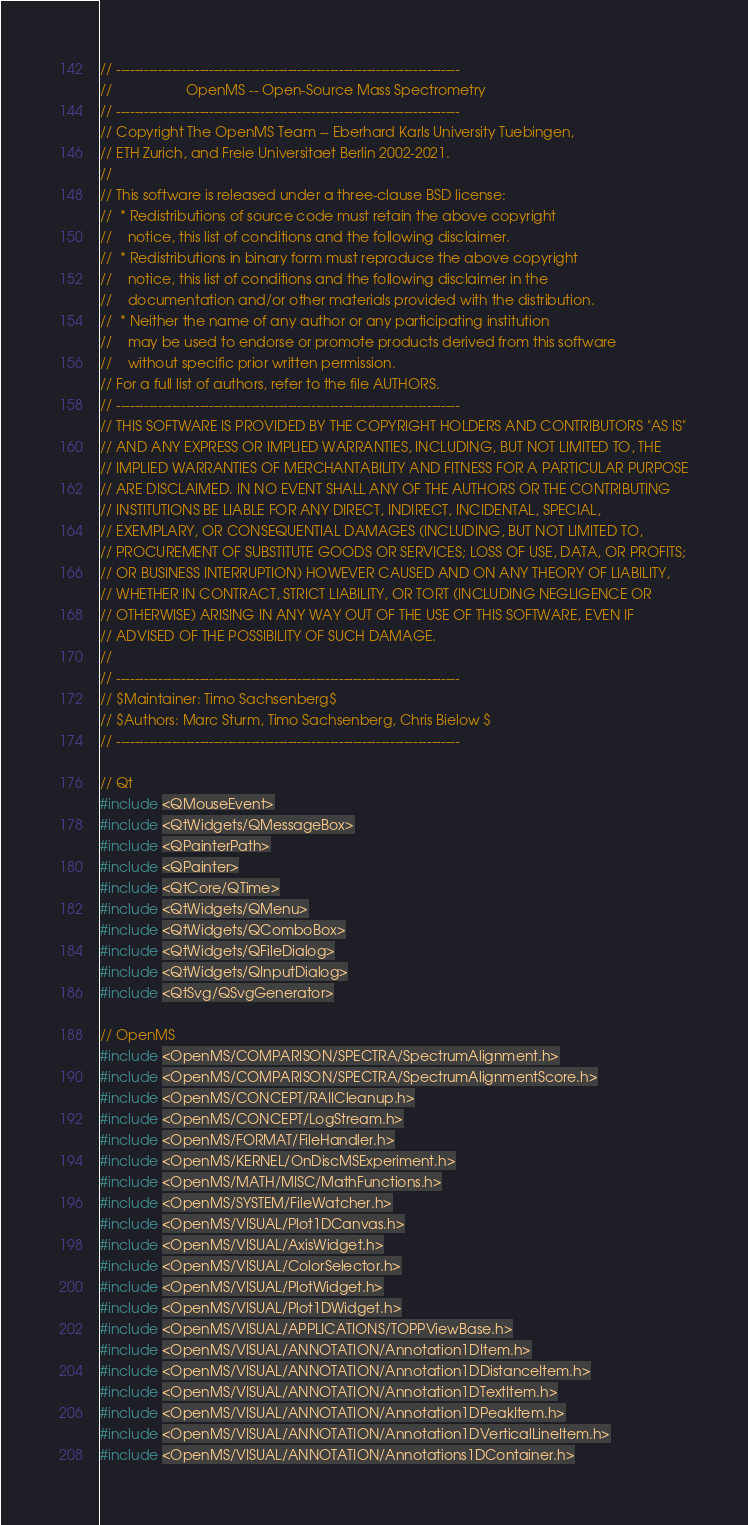Convert code to text. <code><loc_0><loc_0><loc_500><loc_500><_C++_>// --------------------------------------------------------------------------
//                   OpenMS -- Open-Source Mass Spectrometry
// --------------------------------------------------------------------------
// Copyright The OpenMS Team -- Eberhard Karls University Tuebingen,
// ETH Zurich, and Freie Universitaet Berlin 2002-2021.
//
// This software is released under a three-clause BSD license:
//  * Redistributions of source code must retain the above copyright
//    notice, this list of conditions and the following disclaimer.
//  * Redistributions in binary form must reproduce the above copyright
//    notice, this list of conditions and the following disclaimer in the
//    documentation and/or other materials provided with the distribution.
//  * Neither the name of any author or any participating institution
//    may be used to endorse or promote products derived from this software
//    without specific prior written permission.
// For a full list of authors, refer to the file AUTHORS.
// --------------------------------------------------------------------------
// THIS SOFTWARE IS PROVIDED BY THE COPYRIGHT HOLDERS AND CONTRIBUTORS "AS IS"
// AND ANY EXPRESS OR IMPLIED WARRANTIES, INCLUDING, BUT NOT LIMITED TO, THE
// IMPLIED WARRANTIES OF MERCHANTABILITY AND FITNESS FOR A PARTICULAR PURPOSE
// ARE DISCLAIMED. IN NO EVENT SHALL ANY OF THE AUTHORS OR THE CONTRIBUTING
// INSTITUTIONS BE LIABLE FOR ANY DIRECT, INDIRECT, INCIDENTAL, SPECIAL,
// EXEMPLARY, OR CONSEQUENTIAL DAMAGES (INCLUDING, BUT NOT LIMITED TO,
// PROCUREMENT OF SUBSTITUTE GOODS OR SERVICES; LOSS OF USE, DATA, OR PROFITS;
// OR BUSINESS INTERRUPTION) HOWEVER CAUSED AND ON ANY THEORY OF LIABILITY,
// WHETHER IN CONTRACT, STRICT LIABILITY, OR TORT (INCLUDING NEGLIGENCE OR
// OTHERWISE) ARISING IN ANY WAY OUT OF THE USE OF THIS SOFTWARE, EVEN IF
// ADVISED OF THE POSSIBILITY OF SUCH DAMAGE.
//
// --------------------------------------------------------------------------
// $Maintainer: Timo Sachsenberg$
// $Authors: Marc Sturm, Timo Sachsenberg, Chris Bielow $
// --------------------------------------------------------------------------

// Qt
#include <QMouseEvent>
#include <QtWidgets/QMessageBox>
#include <QPainterPath>
#include <QPainter>
#include <QtCore/QTime>
#include <QtWidgets/QMenu>
#include <QtWidgets/QComboBox>
#include <QtWidgets/QFileDialog>
#include <QtWidgets/QInputDialog>
#include <QtSvg/QSvgGenerator>

// OpenMS
#include <OpenMS/COMPARISON/SPECTRA/SpectrumAlignment.h>
#include <OpenMS/COMPARISON/SPECTRA/SpectrumAlignmentScore.h>
#include <OpenMS/CONCEPT/RAIICleanup.h>
#include <OpenMS/CONCEPT/LogStream.h>
#include <OpenMS/FORMAT/FileHandler.h>
#include <OpenMS/KERNEL/OnDiscMSExperiment.h>
#include <OpenMS/MATH/MISC/MathFunctions.h>
#include <OpenMS/SYSTEM/FileWatcher.h>
#include <OpenMS/VISUAL/Plot1DCanvas.h>
#include <OpenMS/VISUAL/AxisWidget.h>
#include <OpenMS/VISUAL/ColorSelector.h>
#include <OpenMS/VISUAL/PlotWidget.h>
#include <OpenMS/VISUAL/Plot1DWidget.h>
#include <OpenMS/VISUAL/APPLICATIONS/TOPPViewBase.h>
#include <OpenMS/VISUAL/ANNOTATION/Annotation1DItem.h>
#include <OpenMS/VISUAL/ANNOTATION/Annotation1DDistanceItem.h>
#include <OpenMS/VISUAL/ANNOTATION/Annotation1DTextItem.h>
#include <OpenMS/VISUAL/ANNOTATION/Annotation1DPeakItem.h>
#include <OpenMS/VISUAL/ANNOTATION/Annotation1DVerticalLineItem.h>
#include <OpenMS/VISUAL/ANNOTATION/Annotations1DContainer.h></code> 